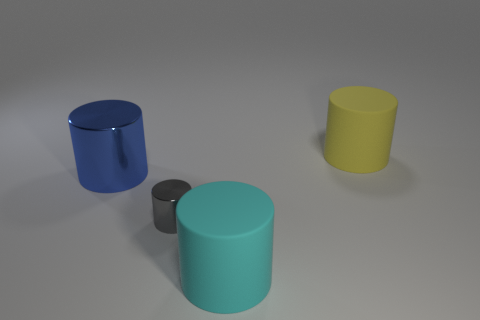What number of things are blue cylinders or big things right of the big cyan thing?
Give a very brief answer. 2. How many other things are the same color as the small cylinder?
Make the answer very short. 0. How many red things are either big metal cylinders or metal cylinders?
Give a very brief answer. 0. Is there a small metal cylinder that is behind the large thing that is on the left side of the shiny thing that is on the right side of the large blue cylinder?
Your response must be concise. No. Are there any other things that have the same size as the cyan thing?
Make the answer very short. Yes. Is the small cylinder the same color as the large shiny cylinder?
Make the answer very short. No. There is a large matte cylinder left of the large yellow object that is behind the big cyan thing; what is its color?
Your response must be concise. Cyan. How many tiny things are either gray cylinders or blue cylinders?
Give a very brief answer. 1. What color is the thing that is on the right side of the tiny gray thing and in front of the big blue metallic cylinder?
Ensure brevity in your answer.  Cyan. Are the yellow cylinder and the small gray object made of the same material?
Provide a succinct answer. No. 